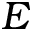<formula> <loc_0><loc_0><loc_500><loc_500>E</formula> 